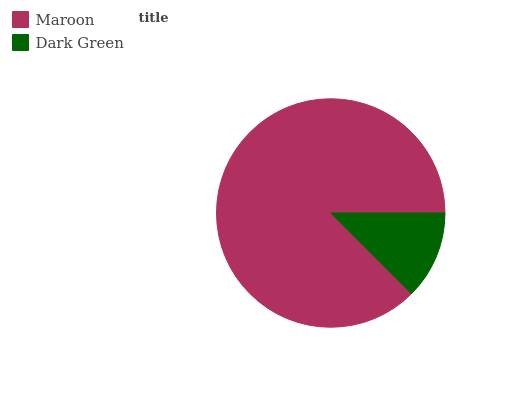Is Dark Green the minimum?
Answer yes or no. Yes. Is Maroon the maximum?
Answer yes or no. Yes. Is Dark Green the maximum?
Answer yes or no. No. Is Maroon greater than Dark Green?
Answer yes or no. Yes. Is Dark Green less than Maroon?
Answer yes or no. Yes. Is Dark Green greater than Maroon?
Answer yes or no. No. Is Maroon less than Dark Green?
Answer yes or no. No. Is Maroon the high median?
Answer yes or no. Yes. Is Dark Green the low median?
Answer yes or no. Yes. Is Dark Green the high median?
Answer yes or no. No. Is Maroon the low median?
Answer yes or no. No. 